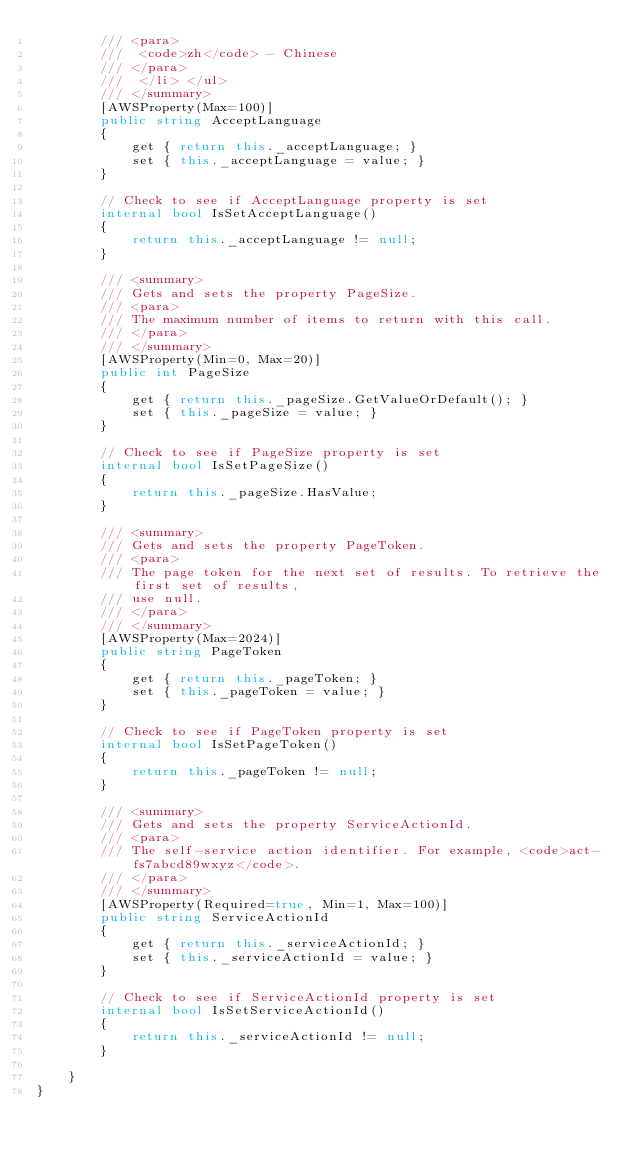<code> <loc_0><loc_0><loc_500><loc_500><_C#_>        /// <para>
        ///  <code>zh</code> - Chinese
        /// </para>
        ///  </li> </ul>
        /// </summary>
        [AWSProperty(Max=100)]
        public string AcceptLanguage
        {
            get { return this._acceptLanguage; }
            set { this._acceptLanguage = value; }
        }

        // Check to see if AcceptLanguage property is set
        internal bool IsSetAcceptLanguage()
        {
            return this._acceptLanguage != null;
        }

        /// <summary>
        /// Gets and sets the property PageSize. 
        /// <para>
        /// The maximum number of items to return with this call.
        /// </para>
        /// </summary>
        [AWSProperty(Min=0, Max=20)]
        public int PageSize
        {
            get { return this._pageSize.GetValueOrDefault(); }
            set { this._pageSize = value; }
        }

        // Check to see if PageSize property is set
        internal bool IsSetPageSize()
        {
            return this._pageSize.HasValue; 
        }

        /// <summary>
        /// Gets and sets the property PageToken. 
        /// <para>
        /// The page token for the next set of results. To retrieve the first set of results,
        /// use null.
        /// </para>
        /// </summary>
        [AWSProperty(Max=2024)]
        public string PageToken
        {
            get { return this._pageToken; }
            set { this._pageToken = value; }
        }

        // Check to see if PageToken property is set
        internal bool IsSetPageToken()
        {
            return this._pageToken != null;
        }

        /// <summary>
        /// Gets and sets the property ServiceActionId. 
        /// <para>
        /// The self-service action identifier. For example, <code>act-fs7abcd89wxyz</code>.
        /// </para>
        /// </summary>
        [AWSProperty(Required=true, Min=1, Max=100)]
        public string ServiceActionId
        {
            get { return this._serviceActionId; }
            set { this._serviceActionId = value; }
        }

        // Check to see if ServiceActionId property is set
        internal bool IsSetServiceActionId()
        {
            return this._serviceActionId != null;
        }

    }
}</code> 